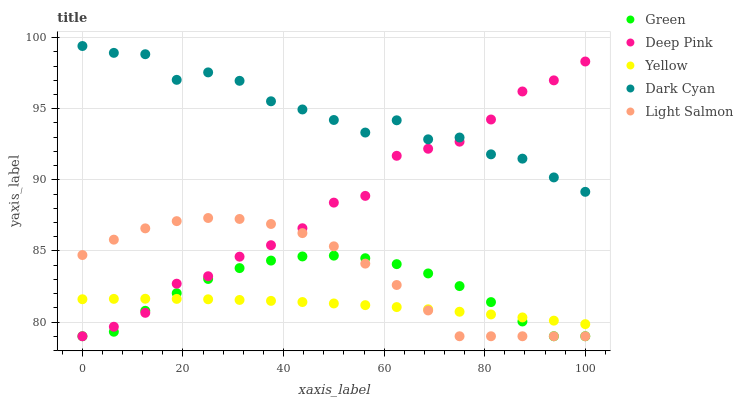Does Yellow have the minimum area under the curve?
Answer yes or no. Yes. Does Dark Cyan have the maximum area under the curve?
Answer yes or no. Yes. Does Light Salmon have the minimum area under the curve?
Answer yes or no. No. Does Light Salmon have the maximum area under the curve?
Answer yes or no. No. Is Yellow the smoothest?
Answer yes or no. Yes. Is Dark Cyan the roughest?
Answer yes or no. Yes. Is Light Salmon the smoothest?
Answer yes or no. No. Is Light Salmon the roughest?
Answer yes or no. No. Does Light Salmon have the lowest value?
Answer yes or no. Yes. Does Yellow have the lowest value?
Answer yes or no. No. Does Dark Cyan have the highest value?
Answer yes or no. Yes. Does Light Salmon have the highest value?
Answer yes or no. No. Is Light Salmon less than Dark Cyan?
Answer yes or no. Yes. Is Dark Cyan greater than Green?
Answer yes or no. Yes. Does Deep Pink intersect Light Salmon?
Answer yes or no. Yes. Is Deep Pink less than Light Salmon?
Answer yes or no. No. Is Deep Pink greater than Light Salmon?
Answer yes or no. No. Does Light Salmon intersect Dark Cyan?
Answer yes or no. No. 